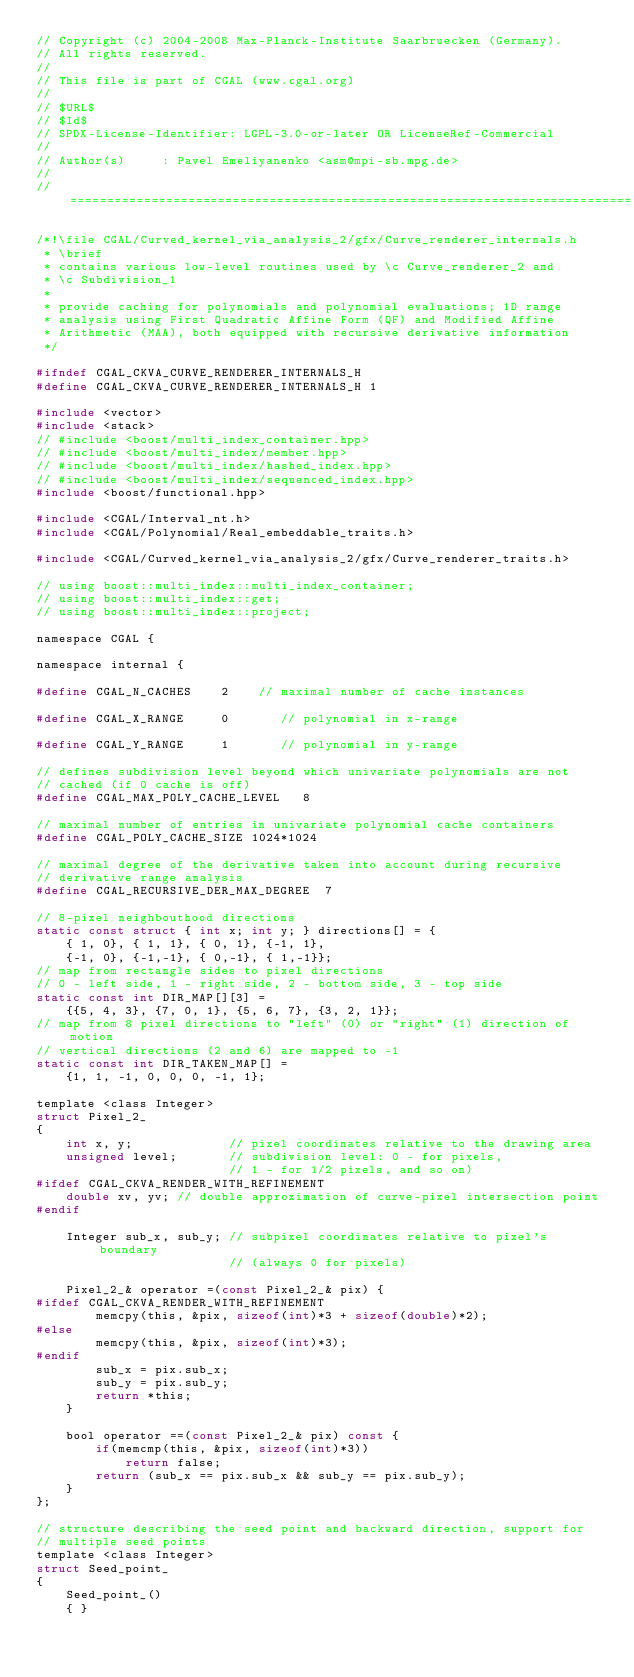Convert code to text. <code><loc_0><loc_0><loc_500><loc_500><_C_>// Copyright (c) 2004-2008 Max-Planck-Institute Saarbruecken (Germany).
// All rights reserved.
//
// This file is part of CGAL (www.cgal.org)
//
// $URL$
// $Id$
// SPDX-License-Identifier: LGPL-3.0-or-later OR LicenseRef-Commercial
//
// Author(s)     : Pavel Emeliyanenko <asm@mpi-sb.mpg.de>
//
// ============================================================================

/*!\file CGAL/Curved_kernel_via_analysis_2/gfx/Curve_renderer_internals.h
 * \brief
 * contains various low-level routines used by \c Curve_renderer_2 and
 * \c Subdivision_1
 *
 * provide caching for polynomials and polynomial evaluations; 1D range
 * analysis using First Quadratic Affine Form (QF) and Modified Affine
 * Arithmetic (MAA), both equipped with recursive derivative information
 */

#ifndef CGAL_CKVA_CURVE_RENDERER_INTERNALS_H
#define CGAL_CKVA_CURVE_RENDERER_INTERNALS_H 1

#include <vector>
#include <stack>
// #include <boost/multi_index_container.hpp>
// #include <boost/multi_index/member.hpp>
// #include <boost/multi_index/hashed_index.hpp>
// #include <boost/multi_index/sequenced_index.hpp>
#include <boost/functional.hpp>

#include <CGAL/Interval_nt.h>
#include <CGAL/Polynomial/Real_embeddable_traits.h>

#include <CGAL/Curved_kernel_via_analysis_2/gfx/Curve_renderer_traits.h>

// using boost::multi_index::multi_index_container;
// using boost::multi_index::get;
// using boost::multi_index::project;

namespace CGAL {

namespace internal {

#define CGAL_N_CACHES    2    // maximal number of cache instances

#define CGAL_X_RANGE     0       // polynomial in x-range

#define CGAL_Y_RANGE     1       // polynomial in y-range

// defines subdivision level beyond which univariate polynomials are not
// cached (if 0 cache is off)
#define CGAL_MAX_POLY_CACHE_LEVEL   8

// maximal number of entries in univariate polynomial cache containers
#define CGAL_POLY_CACHE_SIZE 1024*1024

// maximal degree of the derivative taken into account during recursive
// derivative range analysis
#define CGAL_RECURSIVE_DER_MAX_DEGREE  7

// 8-pixel neighbouthood directions
static const struct { int x; int y; } directions[] = {
    { 1, 0}, { 1, 1}, { 0, 1}, {-1, 1},
    {-1, 0}, {-1,-1}, { 0,-1}, { 1,-1}};
// map from rectangle sides to pixel directions
// 0 - left side, 1 - right side, 2 - bottom side, 3 - top side
static const int DIR_MAP[][3] =
    {{5, 4, 3}, {7, 0, 1}, {5, 6, 7}, {3, 2, 1}};
// map from 8 pixel directions to "left" (0) or "right" (1) direction of motion
// vertical directions (2 and 6) are mapped to -1
static const int DIR_TAKEN_MAP[] =
    {1, 1, -1, 0, 0, 0, -1, 1};

template <class Integer>
struct Pixel_2_
{
    int x, y;             // pixel coordinates relative to the drawing area
    unsigned level;       // subdivision level: 0 - for pixels,
                          // 1 - for 1/2 pixels, and so on)
#ifdef CGAL_CKVA_RENDER_WITH_REFINEMENT
    double xv, yv; // double approximation of curve-pixel intersection point
#endif

    Integer sub_x, sub_y; // subpixel coordinates relative to pixel's boundary
                          // (always 0 for pixels)

    Pixel_2_& operator =(const Pixel_2_& pix) {
#ifdef CGAL_CKVA_RENDER_WITH_REFINEMENT
        memcpy(this, &pix, sizeof(int)*3 + sizeof(double)*2);
#else
        memcpy(this, &pix, sizeof(int)*3);
#endif
        sub_x = pix.sub_x;
        sub_y = pix.sub_y;
        return *this;
    }

    bool operator ==(const Pixel_2_& pix) const {
        if(memcmp(this, &pix, sizeof(int)*3))
            return false;
        return (sub_x == pix.sub_x && sub_y == pix.sub_y);
    }
};

// structure describing the seed point and backward direction, support for
// multiple seed points
template <class Integer>
struct Seed_point_
{
    Seed_point_()
    { }
</code> 